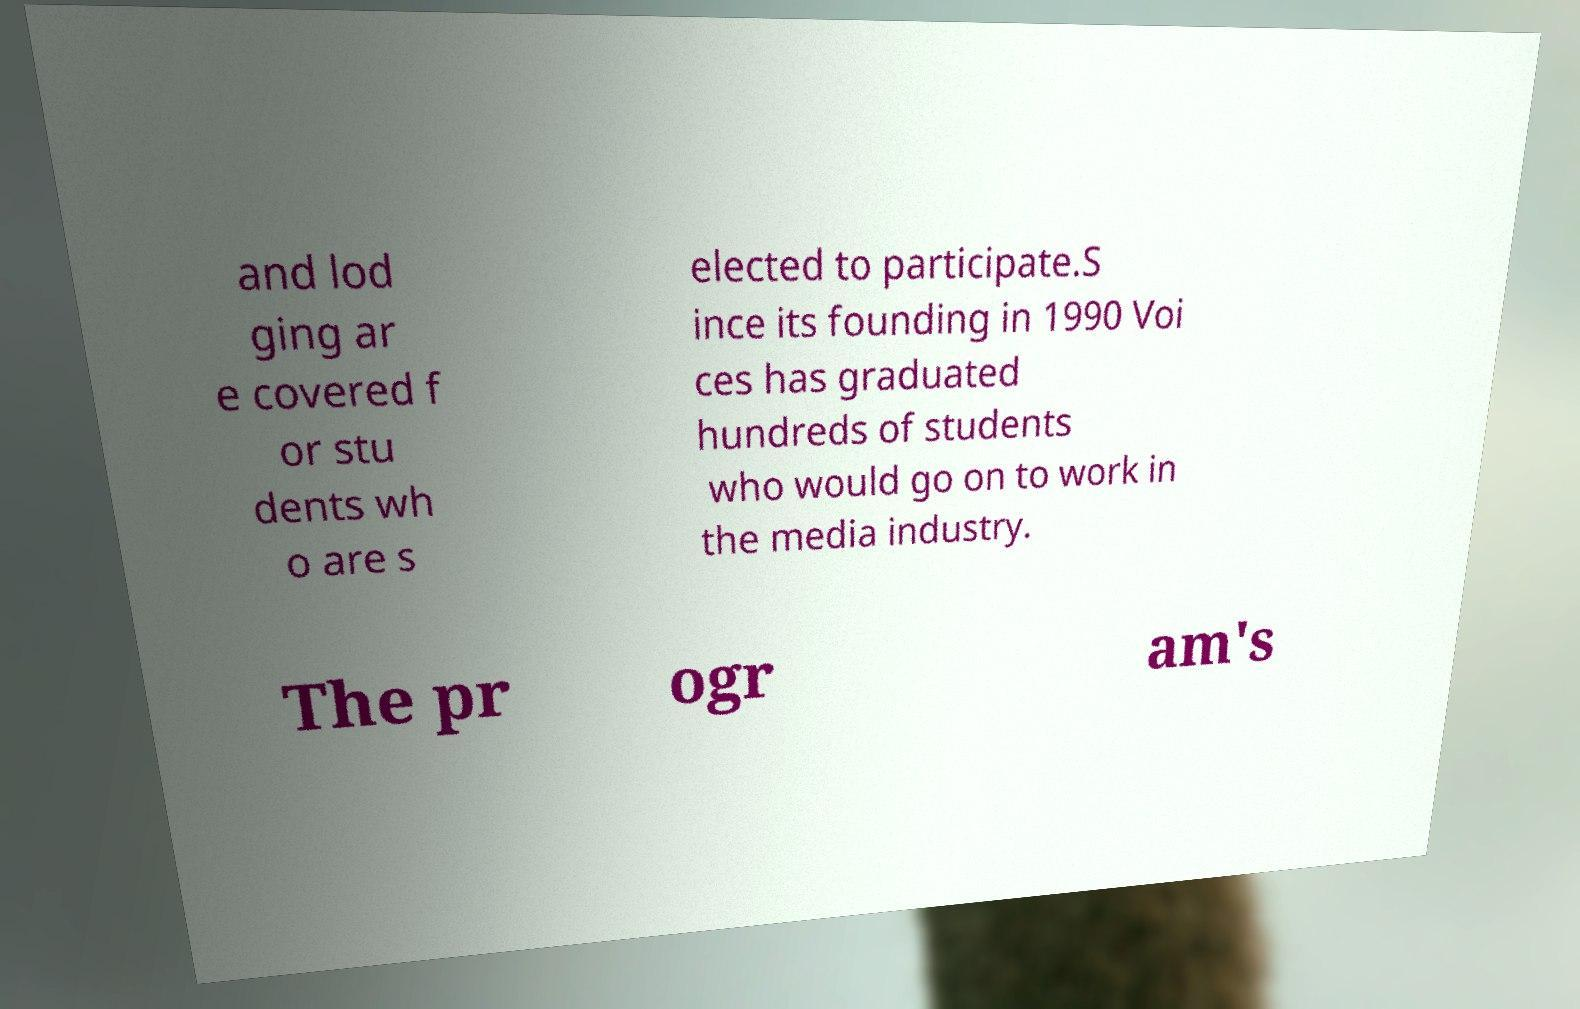Could you assist in decoding the text presented in this image and type it out clearly? and lod ging ar e covered f or stu dents wh o are s elected to participate.S ince its founding in 1990 Voi ces has graduated hundreds of students who would go on to work in the media industry. The pr ogr am's 